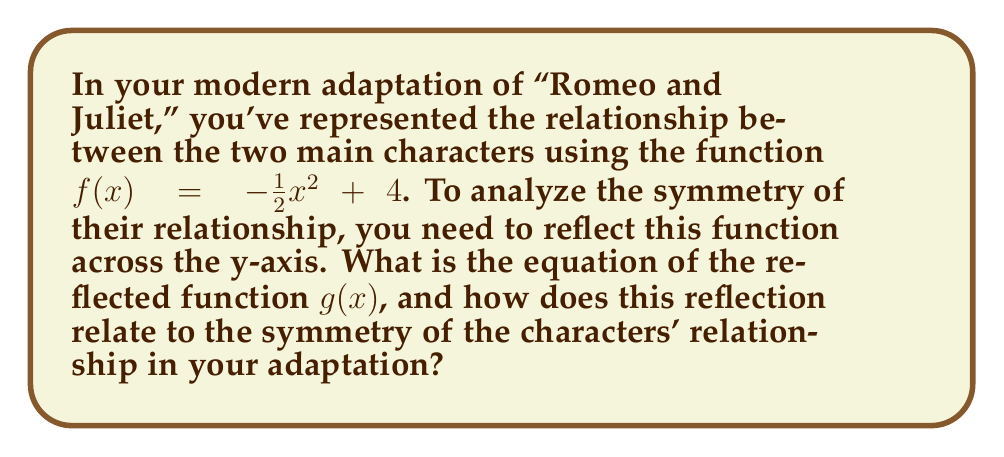Solve this math problem. 1. The original function is $f(x) = -\frac{1}{2}x^2 + 4$.

2. To reflect a function across the y-axis, we replace every $x$ with $-x$ in the original function.

3. Applying this transformation:
   $g(x) = -\frac{1}{2}(-x)^2 + 4$

4. Simplify the squared term:
   $g(x) = -\frac{1}{2}(x^2) + 4$

5. The negative sign and fraction can be combined:
   $g(x) = -\frac{1}{2}x^2 + 4$

6. We can see that $g(x) = f(x)$, which means the function is symmetric about the y-axis.

7. In terms of character relationships, this symmetry implies that the main characters' relationship in the adaptation is balanced and reciprocal. Just as the graph remains unchanged when reflected across the y-axis, their relationship dynamic might be viewed as consistent regardless of which character's perspective is considered.

8. The vertex of the parabola at (0, 4) could represent the peak of their relationship, with the symmetry suggesting equal contributions or similar character arcs from both sides.
Answer: $g(x) = -\frac{1}{2}x^2 + 4$ 